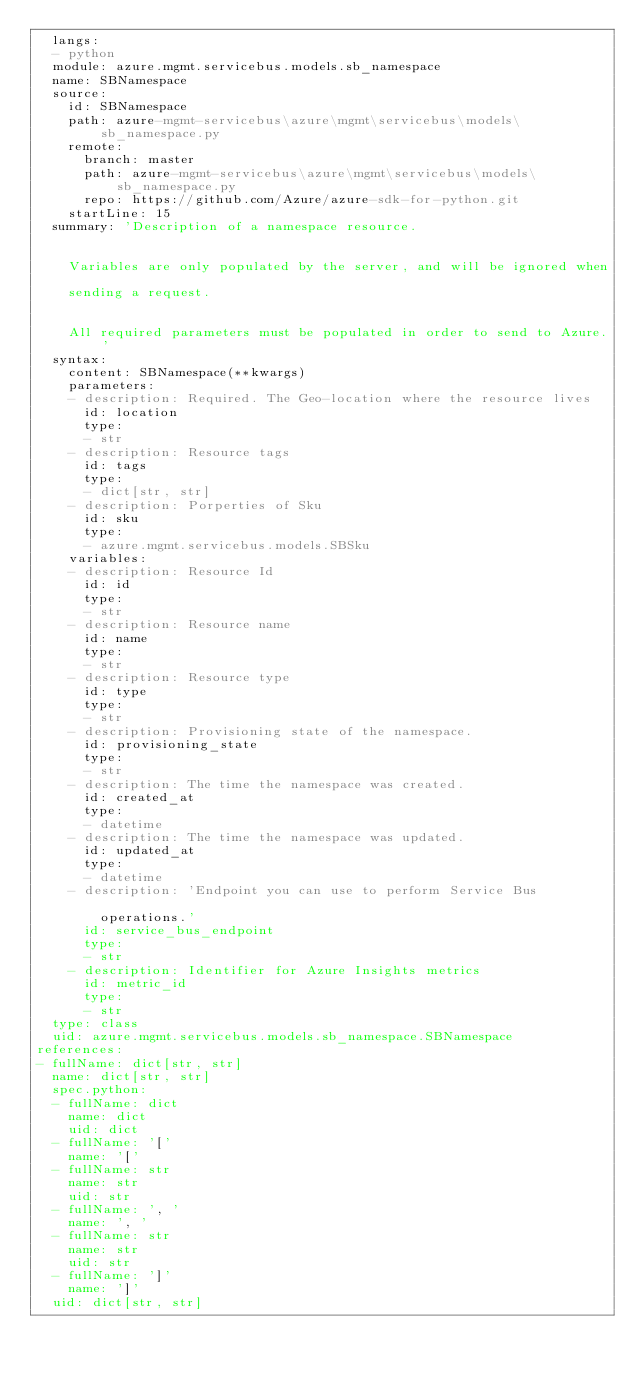Convert code to text. <code><loc_0><loc_0><loc_500><loc_500><_YAML_>  langs:
  - python
  module: azure.mgmt.servicebus.models.sb_namespace
  name: SBNamespace
  source:
    id: SBNamespace
    path: azure-mgmt-servicebus\azure\mgmt\servicebus\models\sb_namespace.py
    remote:
      branch: master
      path: azure-mgmt-servicebus\azure\mgmt\servicebus\models\sb_namespace.py
      repo: https://github.com/Azure/azure-sdk-for-python.git
    startLine: 15
  summary: 'Description of a namespace resource.


    Variables are only populated by the server, and will be ignored when

    sending a request.


    All required parameters must be populated in order to send to Azure.'
  syntax:
    content: SBNamespace(**kwargs)
    parameters:
    - description: Required. The Geo-location where the resource lives
      id: location
      type:
      - str
    - description: Resource tags
      id: tags
      type:
      - dict[str, str]
    - description: Porperties of Sku
      id: sku
      type:
      - azure.mgmt.servicebus.models.SBSku
    variables:
    - description: Resource Id
      id: id
      type:
      - str
    - description: Resource name
      id: name
      type:
      - str
    - description: Resource type
      id: type
      type:
      - str
    - description: Provisioning state of the namespace.
      id: provisioning_state
      type:
      - str
    - description: The time the namespace was created.
      id: created_at
      type:
      - datetime
    - description: The time the namespace was updated.
      id: updated_at
      type:
      - datetime
    - description: 'Endpoint you can use to perform Service Bus

        operations.'
      id: service_bus_endpoint
      type:
      - str
    - description: Identifier for Azure Insights metrics
      id: metric_id
      type:
      - str
  type: class
  uid: azure.mgmt.servicebus.models.sb_namespace.SBNamespace
references:
- fullName: dict[str, str]
  name: dict[str, str]
  spec.python:
  - fullName: dict
    name: dict
    uid: dict
  - fullName: '['
    name: '['
  - fullName: str
    name: str
    uid: str
  - fullName: ', '
    name: ', '
  - fullName: str
    name: str
    uid: str
  - fullName: ']'
    name: ']'
  uid: dict[str, str]
</code> 